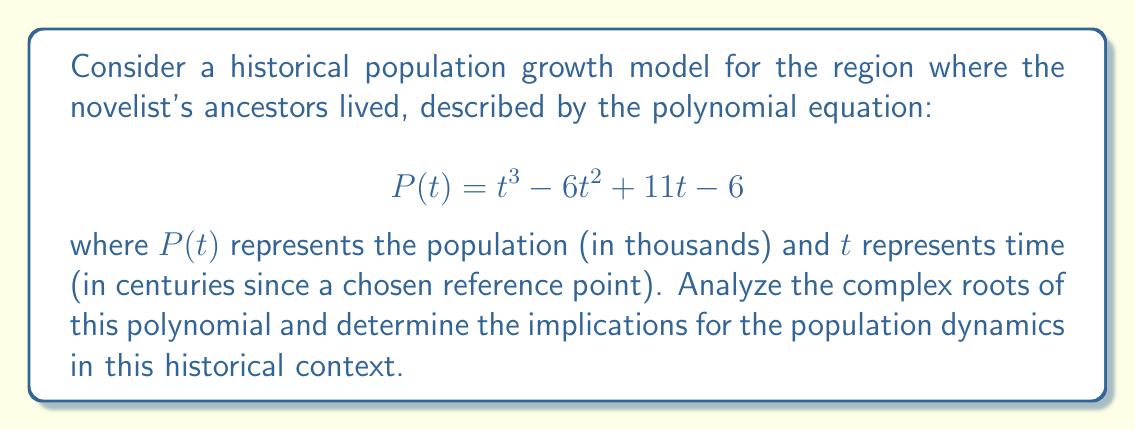Give your solution to this math problem. To analyze the complex roots of the polynomial $P(t) = t^3 - 6t^2 + 11t - 6$, we'll follow these steps:

1) First, let's factor the polynomial. We can see that $t=1$ is a root by inspection:

   $P(1) = 1^3 - 6(1)^2 + 11(1) - 6 = 1 - 6 + 11 - 6 = 0$

2) Dividing $P(t)$ by $(t-1)$:

   $t^3 - 6t^2 + 11t - 6 = (t-1)(t^2 - 5t + 6)$

3) Now we can factor the quadratic term:

   $t^2 - 5t + 6 = (t-2)(t-3)$

4) Therefore, the fully factored polynomial is:

   $P(t) = (t-1)(t-2)(t-3)$

5) The roots of the polynomial are thus $t = 1$, $t = 2$, and $t = 3$.

Interpreting these results in the context of population dynamics:

- All roots are real and positive, indicating that the population model has three equilibrium points over time.
- The roots at $t = 1$, $2$, and $3$ suggest that the population reaches stable points at 1, 2, and 3 centuries after the chosen reference point.
- The fact that there are no complex roots implies that this model doesn't predict oscillatory behavior in the population.
- The polynomial being cubic suggests that the population growth rate changes direction twice over the modeled time period.

From a historical perspective, this could indicate:
- An initial period of growth (from 0 to 1 century)
- A period of slower growth or stagnation (from 1 to 2 centuries)
- A final period of renewed growth or decline (from 2 to 3 centuries)

These changes could correspond to historical events such as migrations, wars, economic shifts, or changes in agricultural practices that affected the population in the region where the novelist's ancestors lived.
Answer: The complex roots of the polynomial $P(t) = t^3 - 6t^2 + 11t - 6$ are:
$t_1 = 1$, $t_2 = 2$, and $t_3 = 3$.

All roots are real, indicating three equilibrium points in the population model at 1, 2, and 3 centuries after the reference point, suggesting significant changes in population dynamics at these times. 